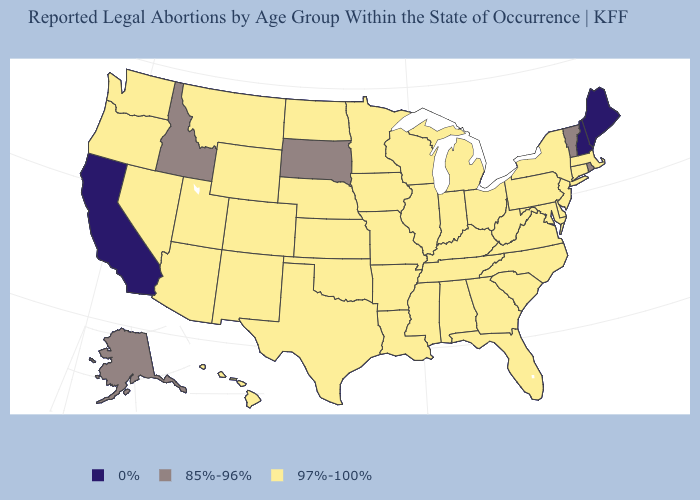What is the value of Virginia?
Quick response, please. 97%-100%. What is the value of Arkansas?
Be succinct. 97%-100%. What is the value of Tennessee?
Answer briefly. 97%-100%. What is the value of Illinois?
Quick response, please. 97%-100%. What is the value of Oklahoma?
Answer briefly. 97%-100%. Name the states that have a value in the range 97%-100%?
Answer briefly. Alabama, Arizona, Arkansas, Colorado, Connecticut, Delaware, Florida, Georgia, Hawaii, Illinois, Indiana, Iowa, Kansas, Kentucky, Louisiana, Maryland, Massachusetts, Michigan, Minnesota, Mississippi, Missouri, Montana, Nebraska, Nevada, New Jersey, New Mexico, New York, North Carolina, North Dakota, Ohio, Oklahoma, Oregon, Pennsylvania, South Carolina, Tennessee, Texas, Utah, Virginia, Washington, West Virginia, Wisconsin, Wyoming. Name the states that have a value in the range 0%?
Concise answer only. California, Maine, New Hampshire. Name the states that have a value in the range 97%-100%?
Quick response, please. Alabama, Arizona, Arkansas, Colorado, Connecticut, Delaware, Florida, Georgia, Hawaii, Illinois, Indiana, Iowa, Kansas, Kentucky, Louisiana, Maryland, Massachusetts, Michigan, Minnesota, Mississippi, Missouri, Montana, Nebraska, Nevada, New Jersey, New Mexico, New York, North Carolina, North Dakota, Ohio, Oklahoma, Oregon, Pennsylvania, South Carolina, Tennessee, Texas, Utah, Virginia, Washington, West Virginia, Wisconsin, Wyoming. Does the map have missing data?
Give a very brief answer. No. Name the states that have a value in the range 85%-96%?
Answer briefly. Alaska, Idaho, Rhode Island, South Dakota, Vermont. Among the states that border Iowa , which have the highest value?
Concise answer only. Illinois, Minnesota, Missouri, Nebraska, Wisconsin. Which states have the lowest value in the Northeast?
Answer briefly. Maine, New Hampshire. How many symbols are there in the legend?
Answer briefly. 3. Among the states that border California , which have the highest value?
Be succinct. Arizona, Nevada, Oregon. 